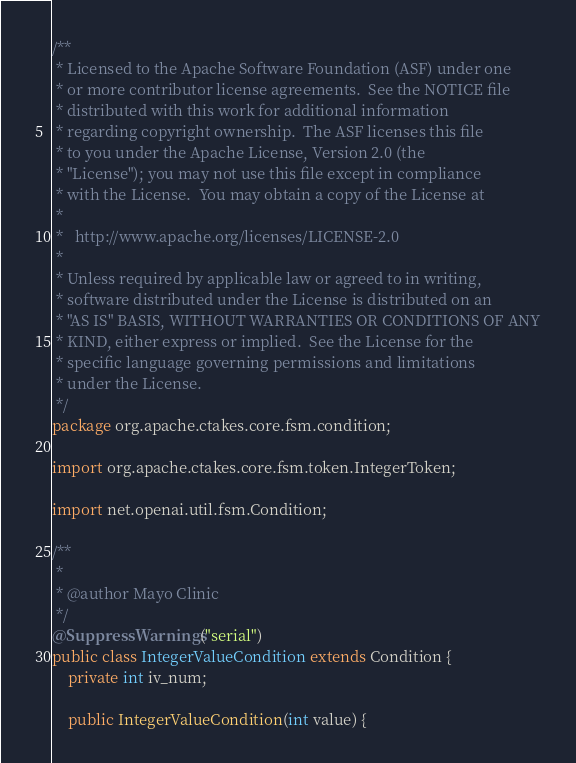Convert code to text. <code><loc_0><loc_0><loc_500><loc_500><_Java_>/**
 * Licensed to the Apache Software Foundation (ASF) under one
 * or more contributor license agreements.  See the NOTICE file
 * distributed with this work for additional information
 * regarding copyright ownership.  The ASF licenses this file
 * to you under the Apache License, Version 2.0 (the
 * "License"); you may not use this file except in compliance
 * with the License.  You may obtain a copy of the License at
 *
 *   http://www.apache.org/licenses/LICENSE-2.0
 *
 * Unless required by applicable law or agreed to in writing,
 * software distributed under the License is distributed on an
 * "AS IS" BASIS, WITHOUT WARRANTIES OR CONDITIONS OF ANY
 * KIND, either express or implied.  See the License for the
 * specific language governing permissions and limitations
 * under the License.
 */
package org.apache.ctakes.core.fsm.condition;

import org.apache.ctakes.core.fsm.token.IntegerToken;

import net.openai.util.fsm.Condition;

/**
 * 
 * @author Mayo Clinic
 */
@SuppressWarnings("serial")
public class IntegerValueCondition extends Condition {
	private int iv_num;

	public IntegerValueCondition(int value) {</code> 